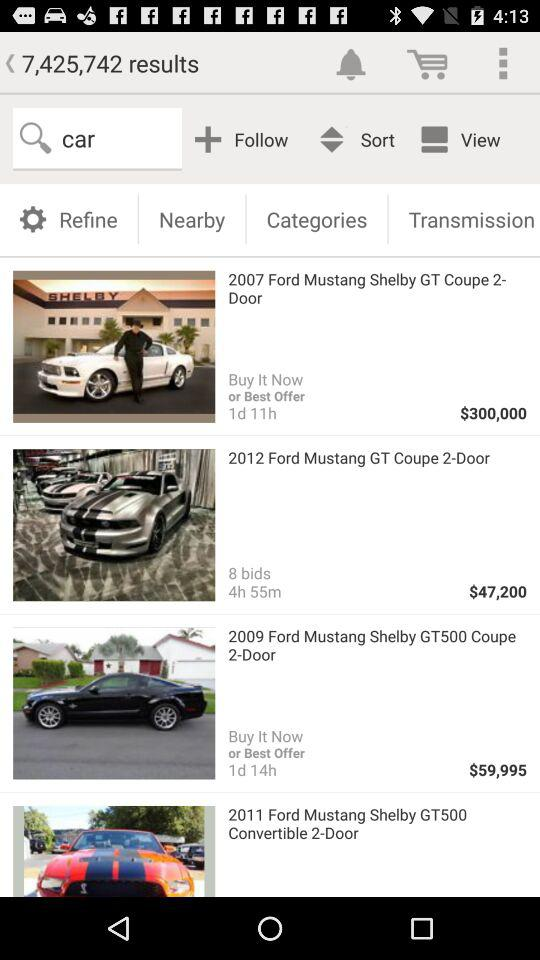What is the name of the car whose price is $47,200? The name of the car is "2012 Ford Mustang GT Coupe 2-Door". 